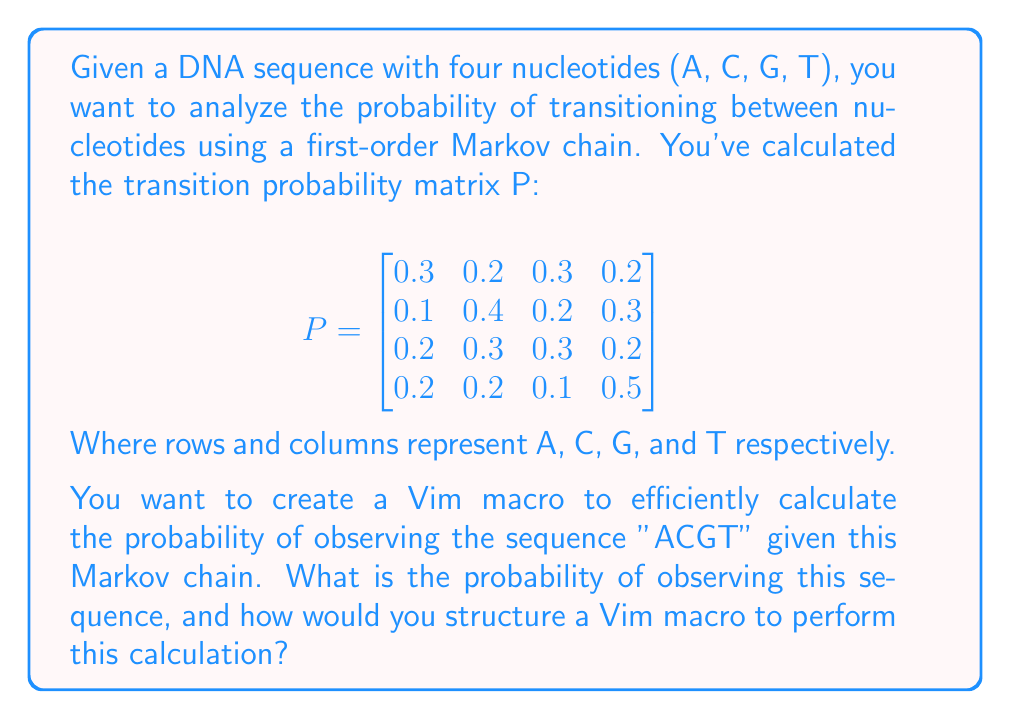Provide a solution to this math problem. To solve this problem, we need to:

1. Understand the Markov chain transition probabilities.
2. Calculate the probability of the sequence "ACGT".
3. Design a Vim macro to perform this calculation efficiently.

Step 1: Understanding the transition matrix
The matrix P represents the probability of transitioning from one nucleotide to another. For example, $P_{1,2} = 0.2$ is the probability of transitioning from A to C.

Step 2: Calculating the sequence probability
For the sequence "ACGT", we need to multiply:
1. The probability of starting with A (assuming equal initial probabilities of 0.25)
2. The probability of transitioning from A to C
3. The probability of transitioning from C to G
4. The probability of transitioning from G to T

Mathematically:
$$P(\text{ACGT}) = 0.25 \times P_{1,2} \times P_{2,3} \times P_{3,4}$$
$$P(\text{ACGT}) = 0.25 \times 0.2 \times 0.2 \times 0.2 = 0.002$$

Step 3: Designing a Vim macro
To create a Vim macro for this calculation:

1. Start recording a macro (e.g., in register 'q'): qq
2. Enter insert mode and type the initial probability: i0.25<Esc>
3. Multiply by first transition: A*0.2<Esc>
4. Repeat for subsequent transitions: 2A*0.2<Esc>
5. Evaluate the expression: V:!bc<Enter>
6. Stop recording the macro: q

To use this macro, place the cursor at the beginning of an empty line and type @q. The macro will insert the calculation and evaluate it using the 'bc' command-line calculator.
Answer: The probability of observing the sequence "ACGT" is 0.002.

A Vim macro to calculate this probability can be created and stored in register 'q' as follows:
qq i0.25<Esc>A*0.2<Esc>2A*0.2<Esc>V:!bc<Enter>q 